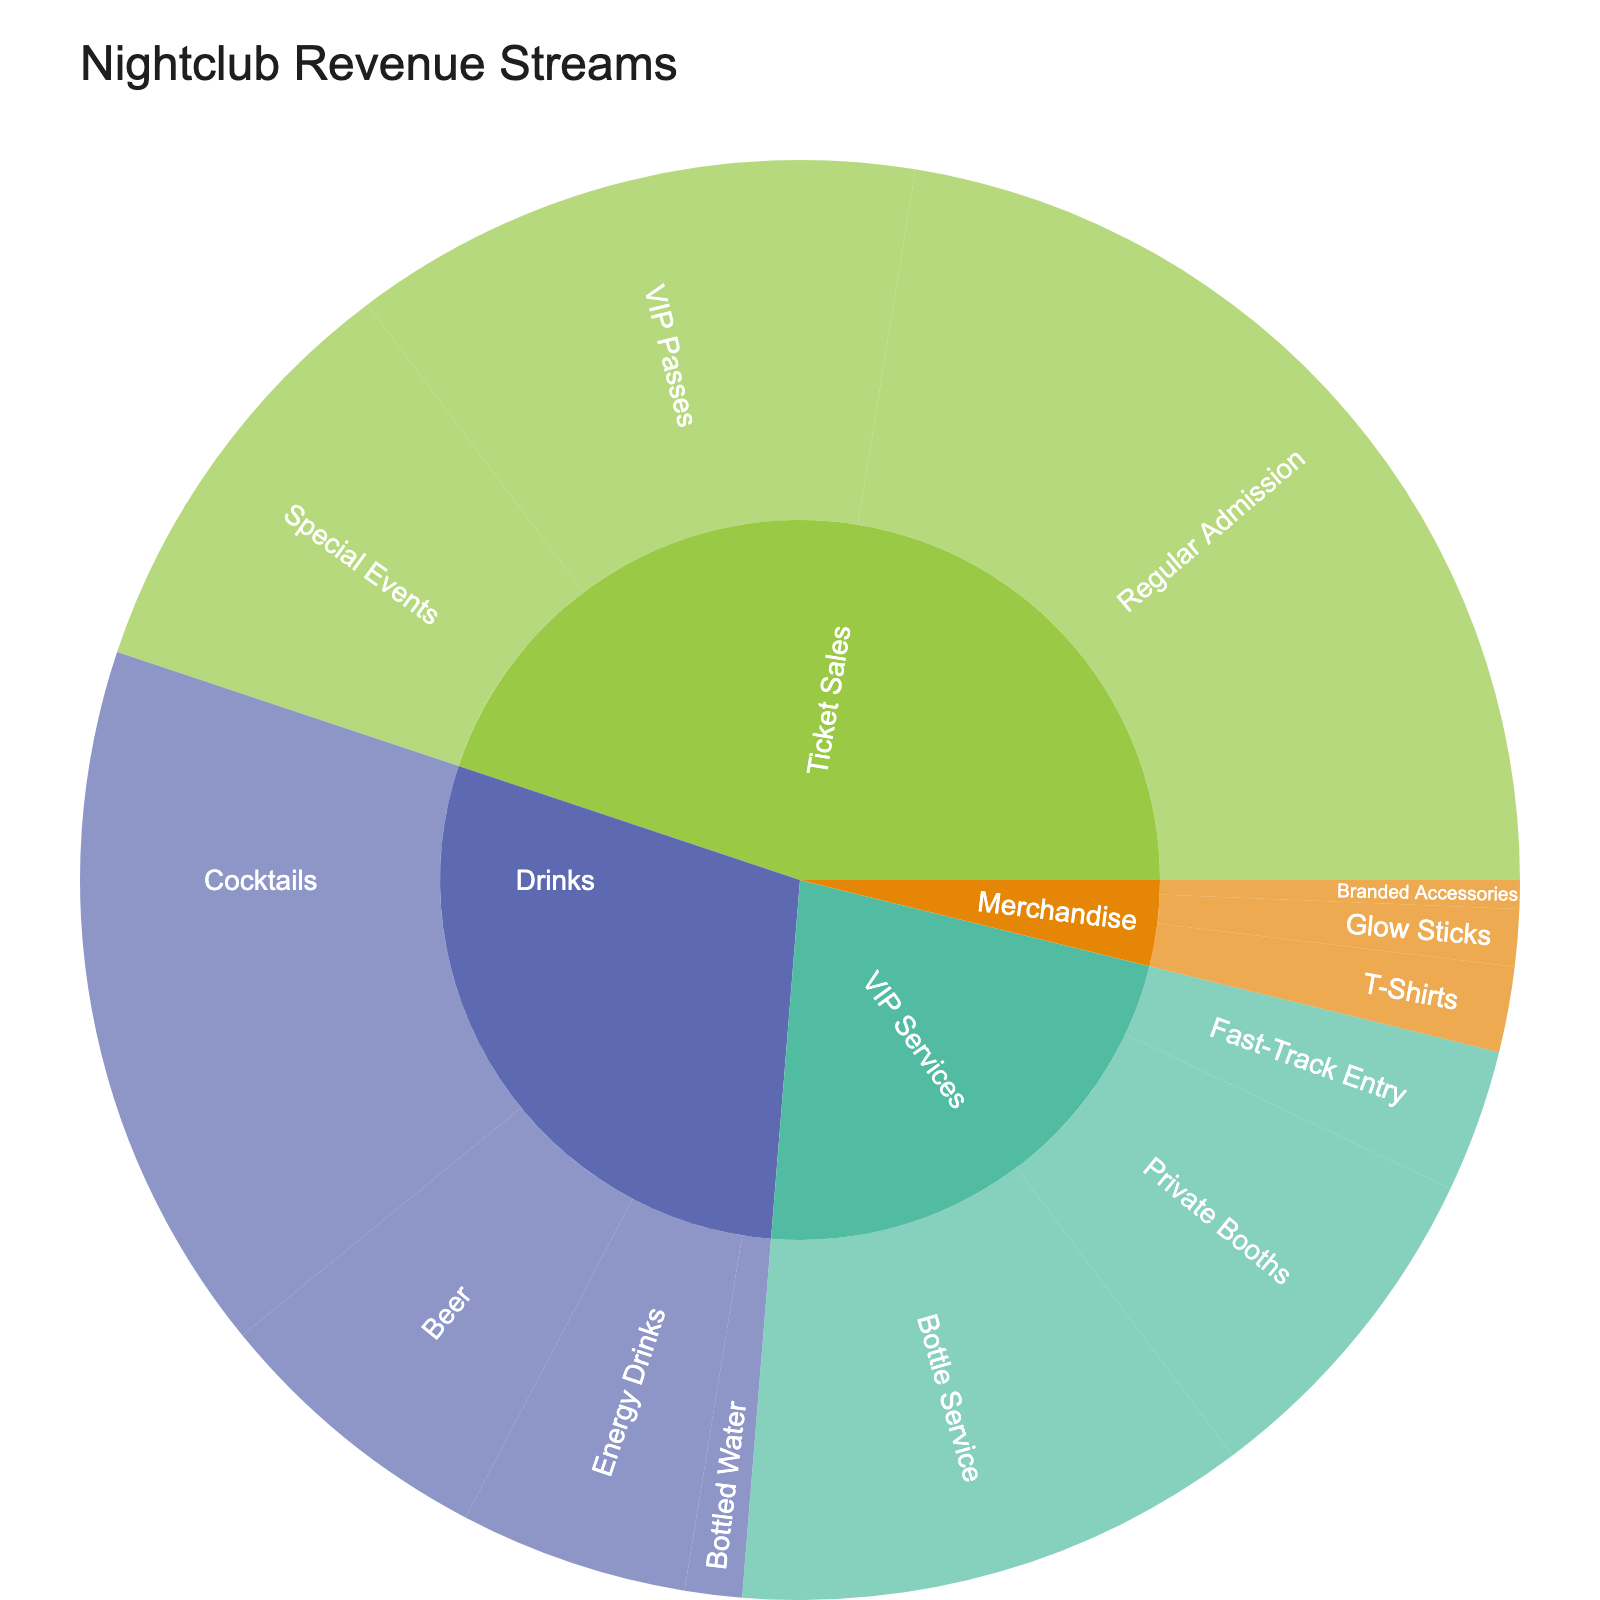what are the main categories displayed on the sunburst plot? The main categories are shown as the outermost layer of the sunburst plot, representing the major revenue streams for the nightclub. These categories are Ticket Sales, Drinks, VIP Services, and Merchandise.
Answer: Ticket Sales, Drinks, VIP Services, Merchandise which subcategory contributes the most to the revenue under Ticket Sales? To determine the subcategory with the highest contribution to Ticket Sales, look at the subcategories under Ticket Sales and compare their values. Regular Admission contributes 35% to Ticket Sales, which is the highest.
Answer: Regular Admission how much of the total revenue comes from VIP Services? Summing up the contributions from all subcategories under VIP Services (Bottle Service, Private Booths, Fast-Track Entry), we get 18% + 12% + 5% = 35%.
Answer: 35% compare the revenue from Cocktails and Bottle Service. Which is higher, and by how much? To compare the revenue from Cocktails and Bottle Service, look at their respective values. Cocktails contribute 25%, and Bottle Service contributes 18%. The difference is 25% - 18% = 7%.
Answer: Cocktails, by 7% what is the least contributing subcategory under Drinks? By examining the subcategories under Drinks and their values, Bottled Water contributes the least with just 2%.
Answer: Bottled Water how do the total revenues from Ticket Sales and Drinks compare? Summing the contributions of the subcategories under Ticket Sales (35% + 20% + 15% = 70%) and Drinks (25% + 10% + 8% + 2% = 45%), we see that Ticket Sales have higher total revenue. 70% is greater than 45%.
Answer: Ticket Sales have higher revenue what percentage of revenue does merchandise contribute? To find the percentage of revenue contributed by Merchandise, sum the contributions of all subcategories under Merchandise (T-Shirts, Glow Sticks, Branded Accessories), which are 3% + 2% + 1% = 6%.
Answer: 6% what is the largest revenue contributor in the plot? Identifying the largest segment in the sunburst plot shows that Regular Admission under Ticket Sales has the largest contribution at 35%.
Answer: Regular Admission how do the revenues from Special Events and VIP Passes compare within Ticket Sales? By examining the subcategories under Ticket Sales, Special Events contribute 15%, and VIP Passes contribute 20%. VIP Passes have a higher revenue contribution.
Answer: VIP Passes have higher revenue what is the combined revenue contribution of Glow Sticks and Branded Accessories? Adding the revenue contributions from Glow Sticks and Branded Accessories, both under Merchandise, we get 2% + 1% = 3%.
Answer: 3% 